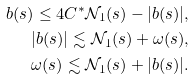Convert formula to latex. <formula><loc_0><loc_0><loc_500><loc_500>b ( s ) \leq 4 C ^ { * } \mathcal { N } _ { 1 } ( s ) - | b ( s ) | , \\ | b ( s ) | \lesssim \mathcal { N } _ { 1 } ( s ) + \omega ( s ) , \\ \omega ( s ) \lesssim \mathcal { N } _ { 1 } ( s ) + | b ( s ) | .</formula> 